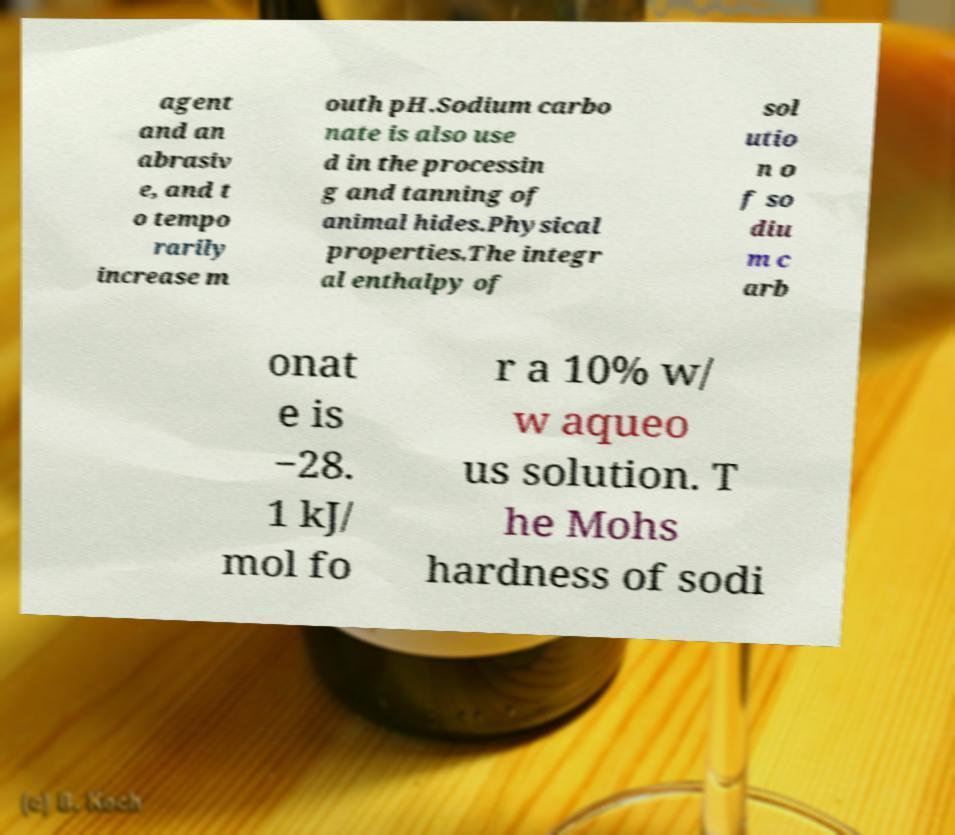I need the written content from this picture converted into text. Can you do that? agent and an abrasiv e, and t o tempo rarily increase m outh pH.Sodium carbo nate is also use d in the processin g and tanning of animal hides.Physical properties.The integr al enthalpy of sol utio n o f so diu m c arb onat e is −28. 1 kJ/ mol fo r a 10% w/ w aqueo us solution. T he Mohs hardness of sodi 